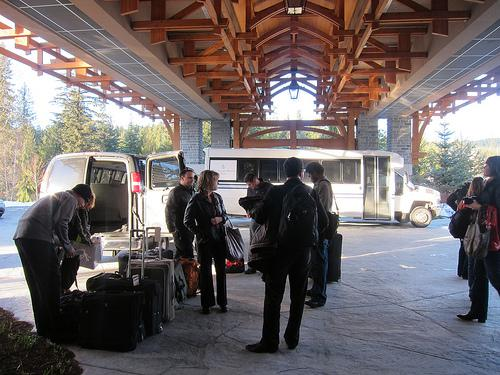Question: where was the photo taken?
Choices:
A. At a bus stop.
B. At the park.
C. In the zoo.
D. In the hotel.
Answer with the letter. Answer: A Question: who is in the photo?
Choices:
A. Dogs.
B. Children.
C. People.
D. Trees.
Answer with the letter. Answer: C Question: when was the photo taken?
Choices:
A. Nighttime.
B. Morning.
C. Evening.
D. Daytime.
Answer with the letter. Answer: D 